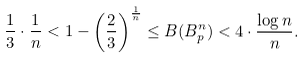<formula> <loc_0><loc_0><loc_500><loc_500>\frac { 1 } { 3 } \cdot \frac { 1 } { n } < 1 - \left ( \frac { 2 } { 3 } \right ) ^ { \frac { 1 } { n } } \leq B ( B ^ { n } _ { p } ) < 4 \cdot \frac { \log n } { n } .</formula> 